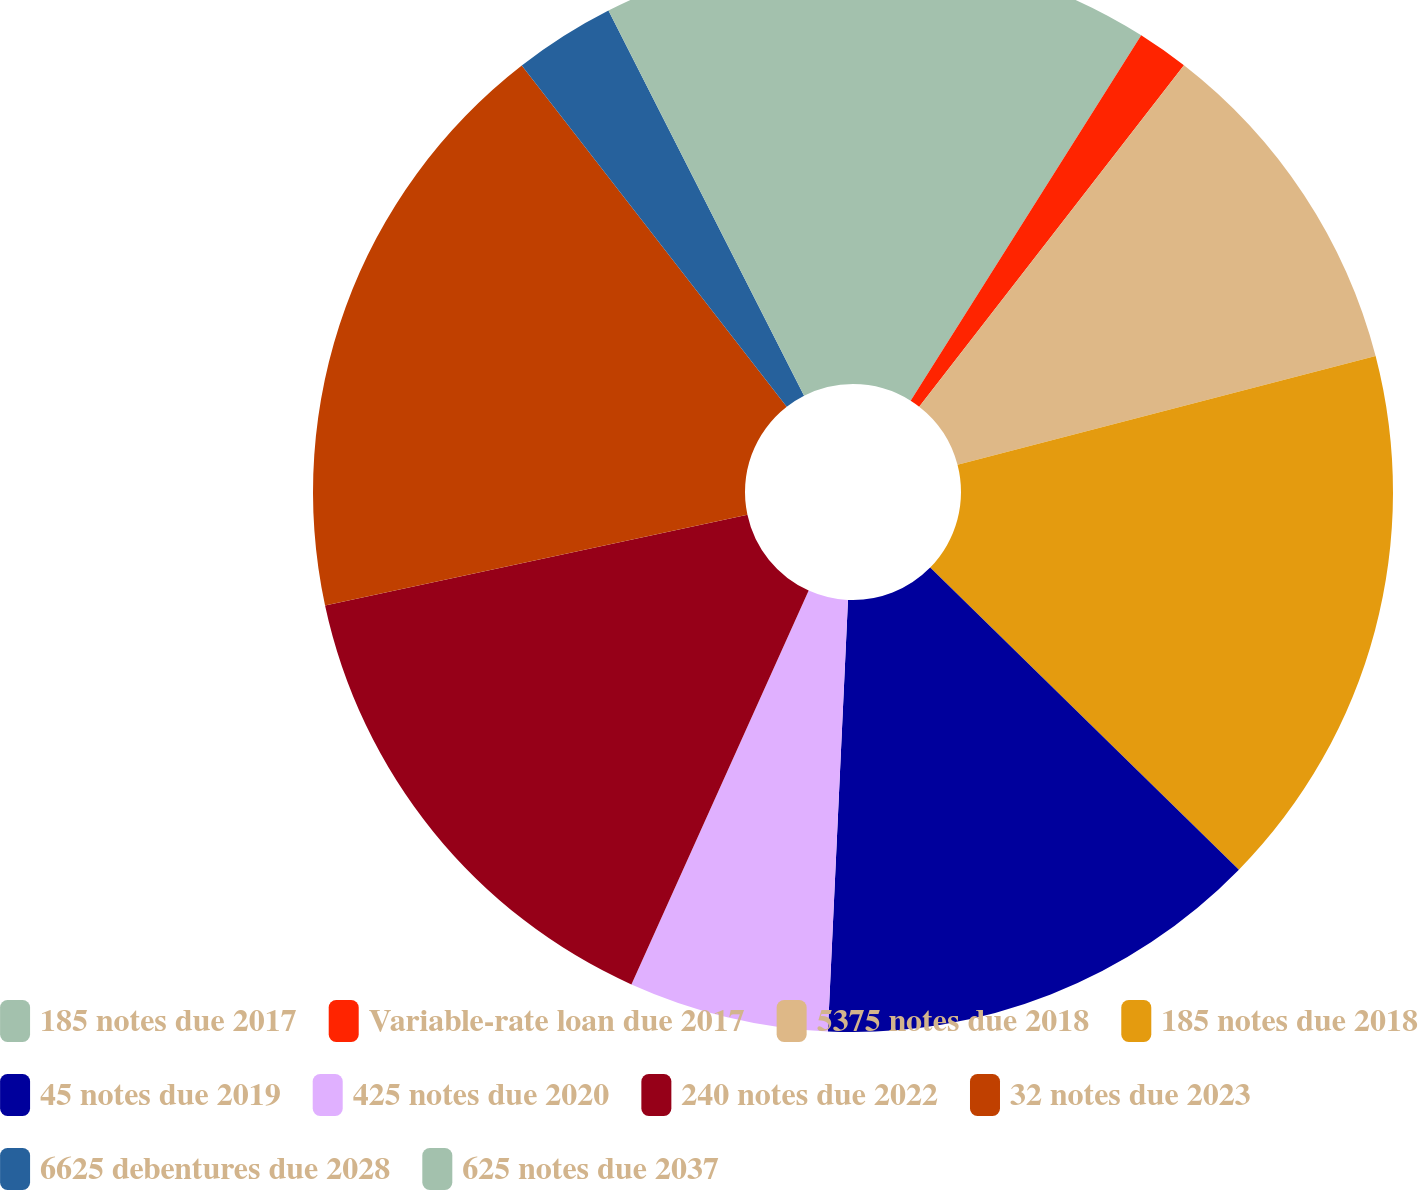Convert chart to OTSL. <chart><loc_0><loc_0><loc_500><loc_500><pie_chart><fcel>185 notes due 2017<fcel>Variable-rate loan due 2017<fcel>5375 notes due 2018<fcel>185 notes due 2018<fcel>45 notes due 2019<fcel>425 notes due 2020<fcel>240 notes due 2022<fcel>32 notes due 2023<fcel>6625 debentures due 2028<fcel>625 notes due 2037<nl><fcel>8.96%<fcel>1.54%<fcel>10.45%<fcel>16.38%<fcel>13.41%<fcel>5.99%<fcel>14.9%<fcel>17.86%<fcel>3.03%<fcel>7.48%<nl></chart> 